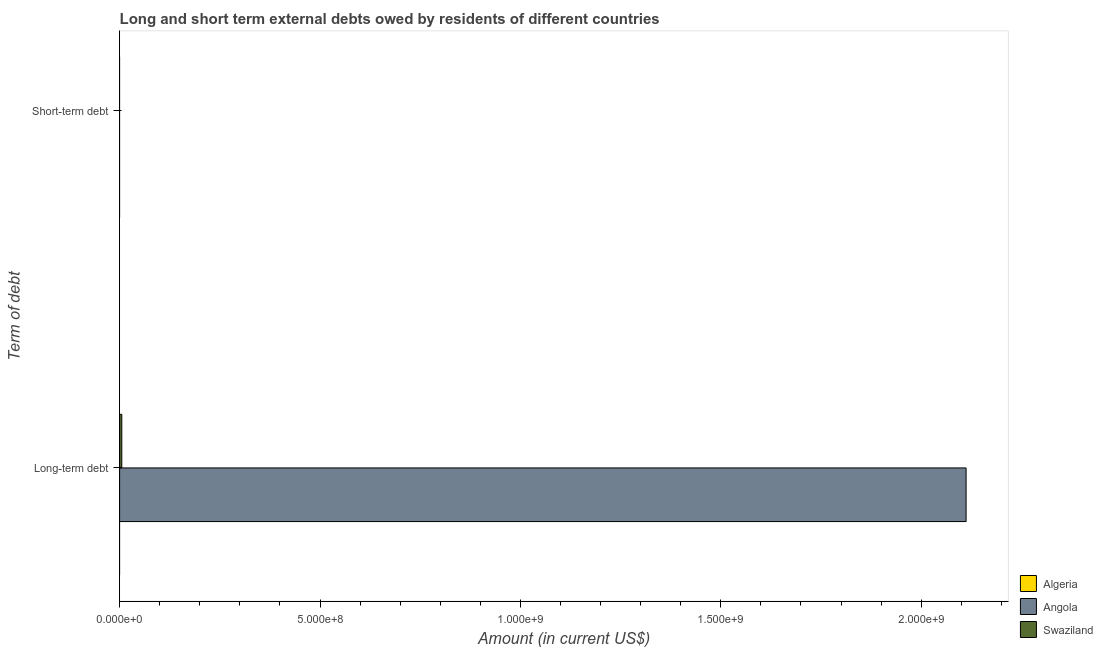How many different coloured bars are there?
Give a very brief answer. 2. Are the number of bars per tick equal to the number of legend labels?
Give a very brief answer. No. Are the number of bars on each tick of the Y-axis equal?
Give a very brief answer. No. How many bars are there on the 2nd tick from the top?
Give a very brief answer. 2. What is the label of the 2nd group of bars from the top?
Your response must be concise. Long-term debt. What is the long-term debts owed by residents in Algeria?
Give a very brief answer. 0. Across all countries, what is the maximum long-term debts owed by residents?
Make the answer very short. 2.11e+09. In which country was the long-term debts owed by residents maximum?
Your answer should be compact. Angola. What is the total long-term debts owed by residents in the graph?
Your answer should be very brief. 2.12e+09. What is the difference between the long-term debts owed by residents in Swaziland and the short-term debts owed by residents in Angola?
Your answer should be compact. 5.42e+06. Are the values on the major ticks of X-axis written in scientific E-notation?
Provide a short and direct response. Yes. Does the graph contain grids?
Keep it short and to the point. No. What is the title of the graph?
Your answer should be compact. Long and short term external debts owed by residents of different countries. Does "Iran" appear as one of the legend labels in the graph?
Ensure brevity in your answer.  No. What is the label or title of the X-axis?
Provide a succinct answer. Amount (in current US$). What is the label or title of the Y-axis?
Make the answer very short. Term of debt. What is the Amount (in current US$) in Angola in Long-term debt?
Your answer should be very brief. 2.11e+09. What is the Amount (in current US$) of Swaziland in Long-term debt?
Give a very brief answer. 5.42e+06. What is the Amount (in current US$) of Algeria in Short-term debt?
Ensure brevity in your answer.  0. Across all Term of debt, what is the maximum Amount (in current US$) of Angola?
Offer a very short reply. 2.11e+09. Across all Term of debt, what is the maximum Amount (in current US$) of Swaziland?
Provide a short and direct response. 5.42e+06. Across all Term of debt, what is the minimum Amount (in current US$) of Swaziland?
Give a very brief answer. 0. What is the total Amount (in current US$) in Algeria in the graph?
Provide a short and direct response. 0. What is the total Amount (in current US$) in Angola in the graph?
Give a very brief answer. 2.11e+09. What is the total Amount (in current US$) in Swaziland in the graph?
Offer a terse response. 5.42e+06. What is the average Amount (in current US$) of Angola per Term of debt?
Provide a succinct answer. 1.06e+09. What is the average Amount (in current US$) in Swaziland per Term of debt?
Your answer should be very brief. 2.71e+06. What is the difference between the Amount (in current US$) of Angola and Amount (in current US$) of Swaziland in Long-term debt?
Provide a succinct answer. 2.11e+09. What is the difference between the highest and the lowest Amount (in current US$) in Angola?
Your answer should be compact. 2.11e+09. What is the difference between the highest and the lowest Amount (in current US$) in Swaziland?
Offer a very short reply. 5.42e+06. 